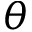Convert formula to latex. <formula><loc_0><loc_0><loc_500><loc_500>\theta</formula> 